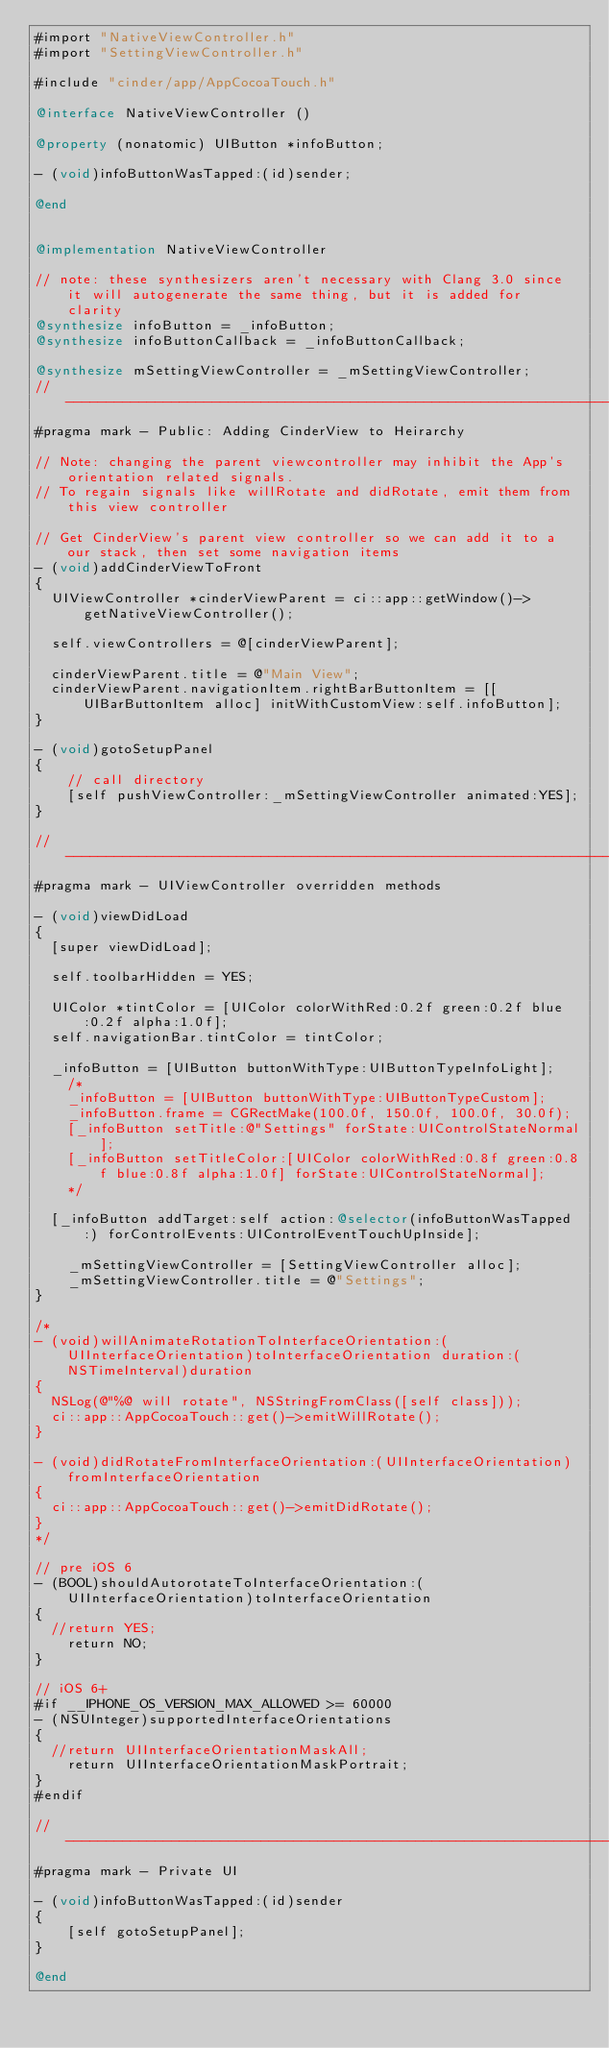<code> <loc_0><loc_0><loc_500><loc_500><_ObjectiveC_>#import "NativeViewController.h"
#import "SettingViewController.h"

#include "cinder/app/AppCocoaTouch.h"

@interface NativeViewController ()

@property (nonatomic) UIButton *infoButton;

- (void)infoButtonWasTapped:(id)sender;

@end


@implementation NativeViewController

// note: these synthesizers aren't necessary with Clang 3.0 since it will autogenerate the same thing, but it is added for clarity
@synthesize infoButton = _infoButton;
@synthesize infoButtonCallback = _infoButtonCallback;

@synthesize mSettingViewController = _mSettingViewController;
// -------------------------------------------------------------------------------------------------
#pragma mark - Public: Adding CinderView to Heirarchy

// Note: changing the parent viewcontroller may inhibit the App's orientation related signals.
// To regain signals like willRotate and didRotate, emit them from this view controller

// Get CinderView's parent view controller so we can add it to a our stack, then set some navigation items
- (void)addCinderViewToFront
{
	UIViewController *cinderViewParent = ci::app::getWindow()->getNativeViewController();

	self.viewControllers = @[cinderViewParent];

	cinderViewParent.title = @"Main View";
	cinderViewParent.navigationItem.rightBarButtonItem = [[UIBarButtonItem alloc] initWithCustomView:self.infoButton];    
}

- (void)gotoSetupPanel
{
    // call directory
    [self pushViewController:_mSettingViewController animated:YES];
}

// -------------------------------------------------------------------------------------------------
#pragma mark - UIViewController overridden methods

- (void)viewDidLoad
{
	[super viewDidLoad];

	self.toolbarHidden = YES;
    
	UIColor *tintColor = [UIColor colorWithRed:0.2f green:0.2f blue:0.2f alpha:1.0f];
	self.navigationBar.tintColor = tintColor;
    
	_infoButton = [UIButton buttonWithType:UIButtonTypeInfoLight];
    /*
    _infoButton = [UIButton buttonWithType:UIButtonTypeCustom];
    _infoButton.frame = CGRectMake(100.0f, 150.0f, 100.0f, 30.0f);
    [_infoButton setTitle:@"Settings" forState:UIControlStateNormal];
    [_infoButton setTitleColor:[UIColor colorWithRed:0.8f green:0.8f blue:0.8f alpha:1.0f] forState:UIControlStateNormal];
    */
    
	[_infoButton addTarget:self action:@selector(infoButtonWasTapped:) forControlEvents:UIControlEventTouchUpInside];
    
    _mSettingViewController = [SettingViewController alloc];
    _mSettingViewController.title = @"Settings";    
}

/*
- (void)willAnimateRotationToInterfaceOrientation:(UIInterfaceOrientation)toInterfaceOrientation duration:(NSTimeInterval)duration
{
	NSLog(@"%@ will rotate", NSStringFromClass([self class]));
	ci::app::AppCocoaTouch::get()->emitWillRotate();
}

- (void)didRotateFromInterfaceOrientation:(UIInterfaceOrientation)fromInterfaceOrientation
{
	ci::app::AppCocoaTouch::get()->emitDidRotate();
}
*/

// pre iOS 6
- (BOOL)shouldAutorotateToInterfaceOrientation:(UIInterfaceOrientation)toInterfaceOrientation
{
	//return YES;
    return NO;
}

// iOS 6+
#if __IPHONE_OS_VERSION_MAX_ALLOWED >= 60000
- (NSUInteger)supportedInterfaceOrientations
{
	//return UIInterfaceOrientationMaskAll;    
    return UIInterfaceOrientationMaskPortrait;
}
#endif

// -------------------------------------------------------------------------------------------------
#pragma mark - Private UI

- (void)infoButtonWasTapped:(id)sender
{
    [self gotoSetupPanel];
}

@end
</code> 